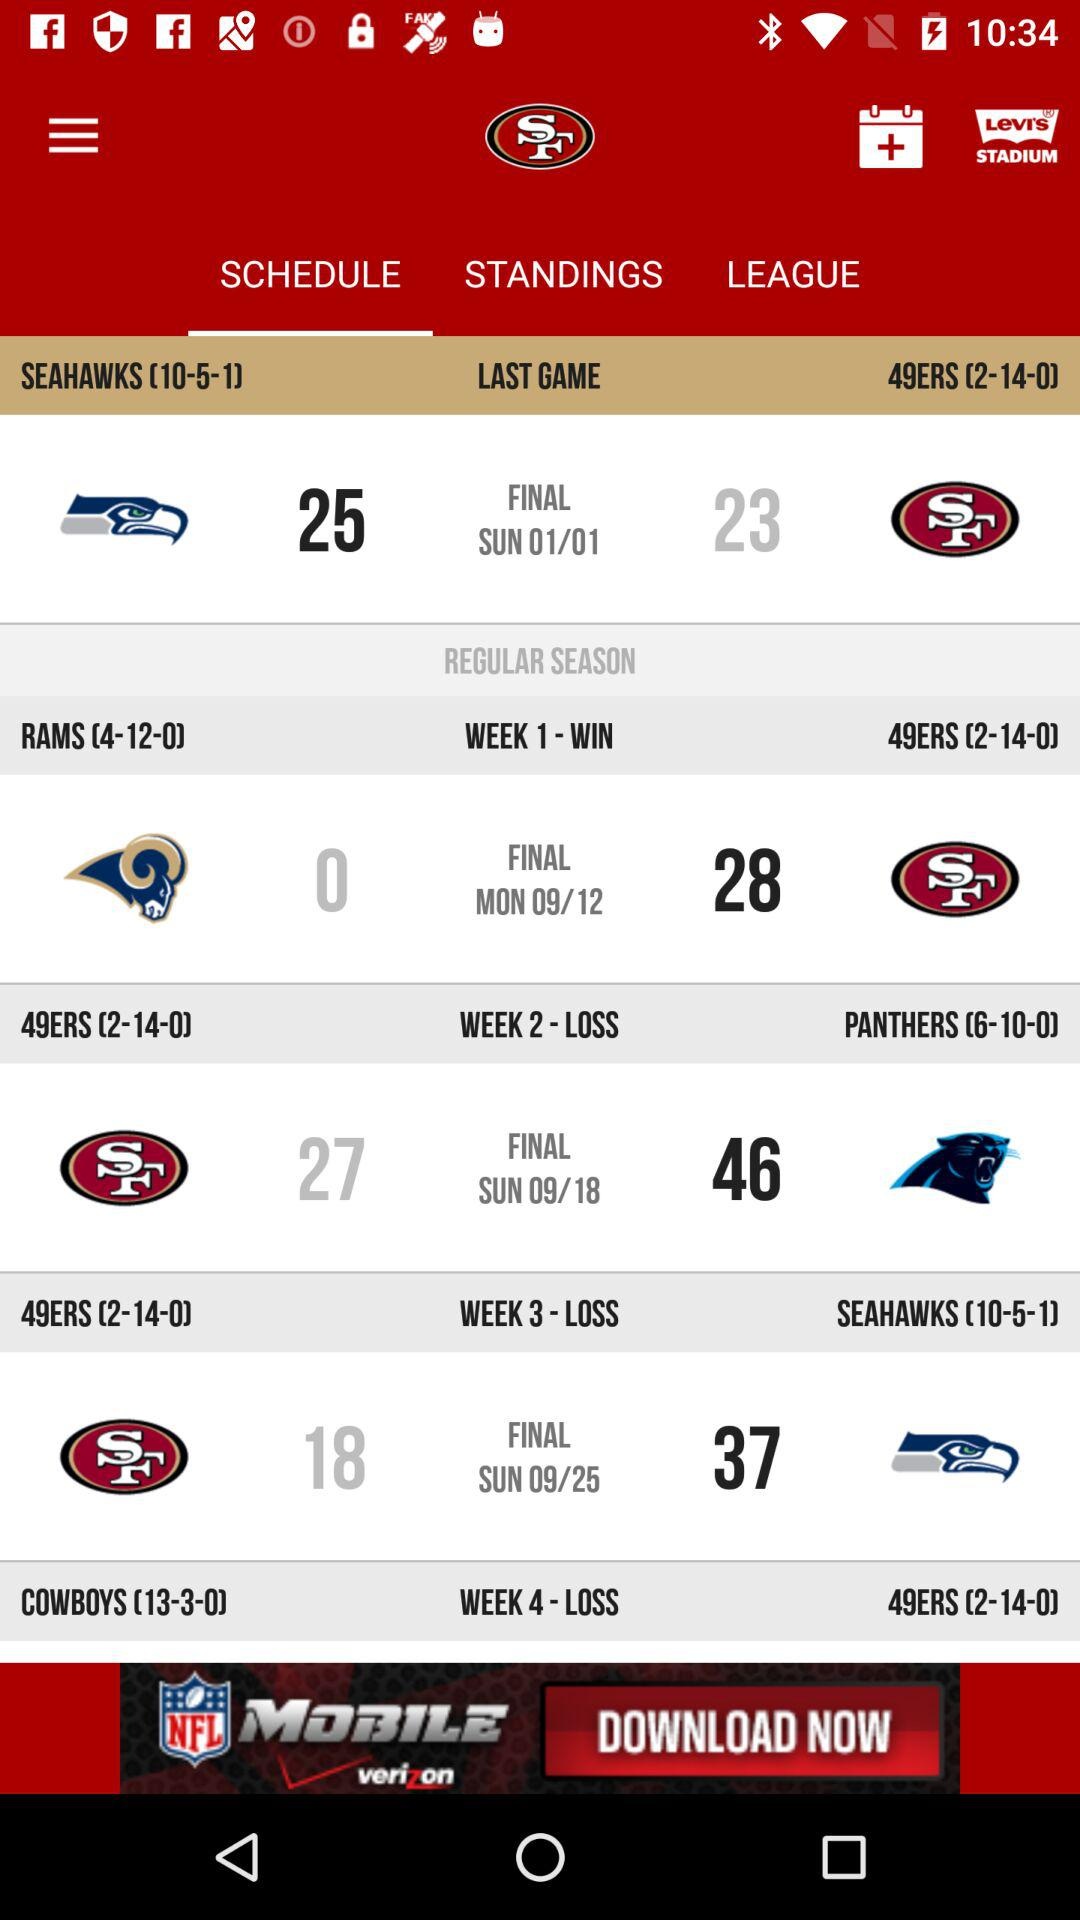Which tab am I on? You are on the "SCHEDULE" tab. 